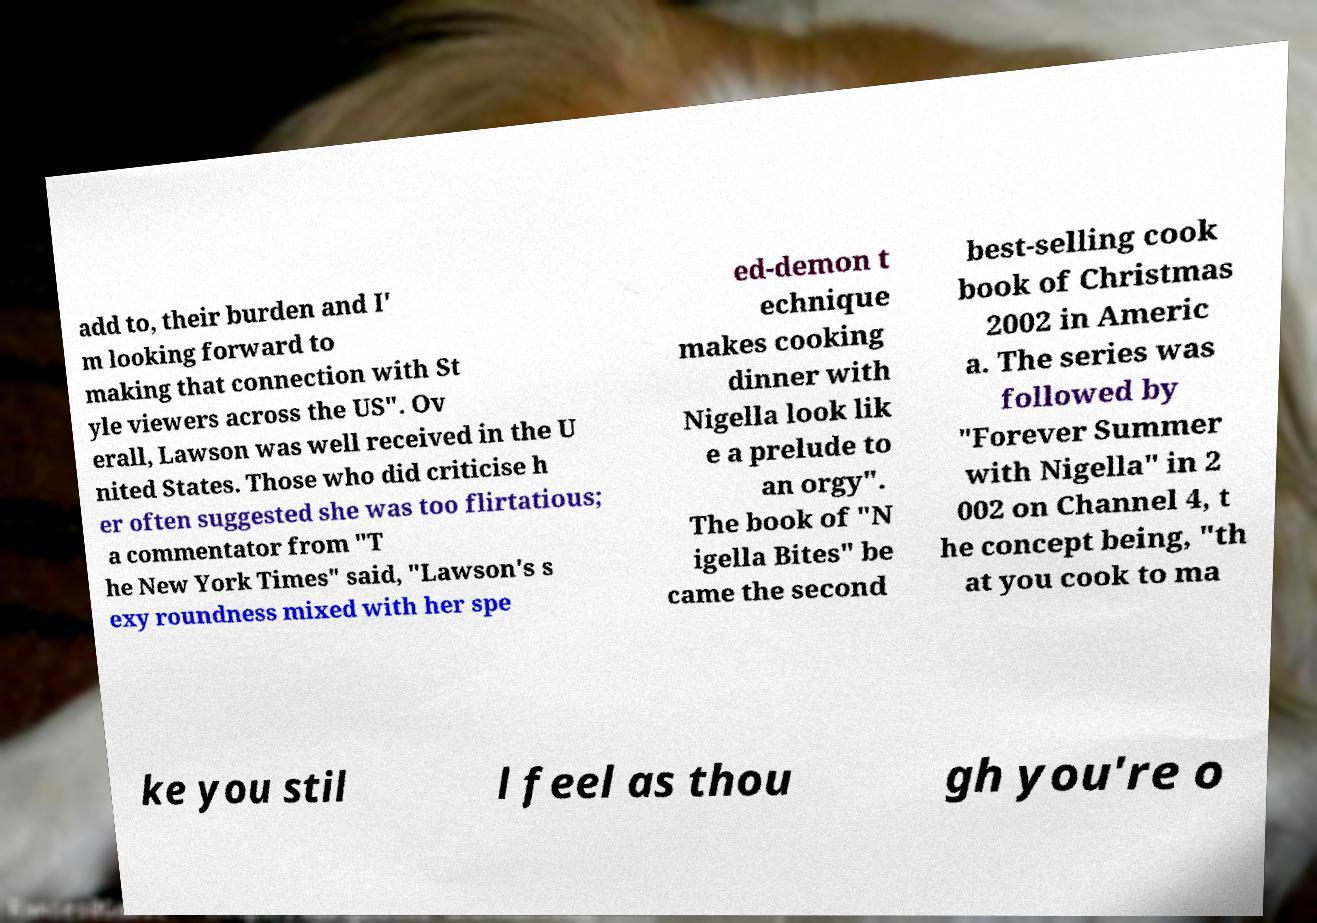There's text embedded in this image that I need extracted. Can you transcribe it verbatim? add to, their burden and I' m looking forward to making that connection with St yle viewers across the US". Ov erall, Lawson was well received in the U nited States. Those who did criticise h er often suggested she was too flirtatious; a commentator from "T he New York Times" said, "Lawson's s exy roundness mixed with her spe ed-demon t echnique makes cooking dinner with Nigella look lik e a prelude to an orgy". The book of "N igella Bites" be came the second best-selling cook book of Christmas 2002 in Americ a. The series was followed by "Forever Summer with Nigella" in 2 002 on Channel 4, t he concept being, "th at you cook to ma ke you stil l feel as thou gh you're o 